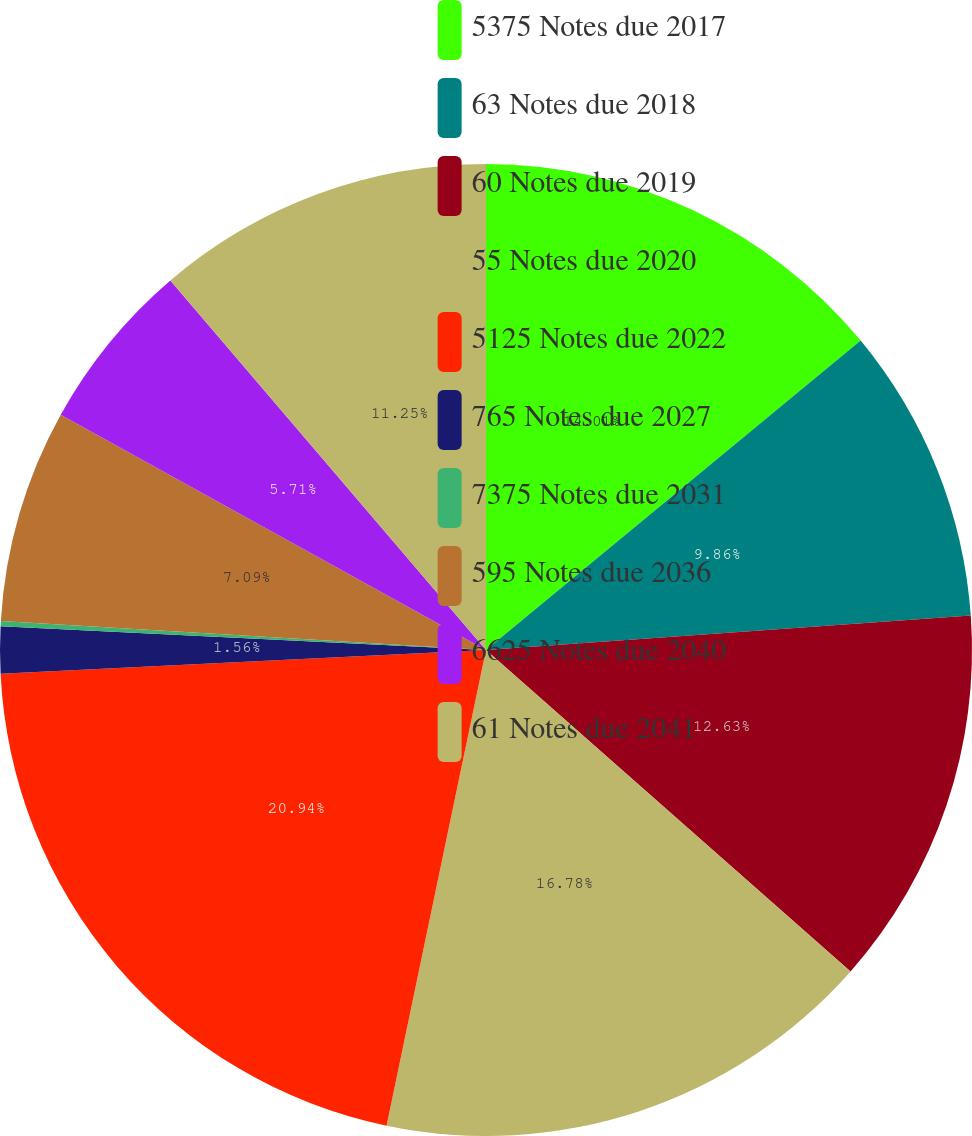<chart> <loc_0><loc_0><loc_500><loc_500><pie_chart><fcel>5375 Notes due 2017<fcel>63 Notes due 2018<fcel>60 Notes due 2019<fcel>55 Notes due 2020<fcel>5125 Notes due 2022<fcel>765 Notes due 2027<fcel>7375 Notes due 2031<fcel>595 Notes due 2036<fcel>6625 Notes due 2040<fcel>61 Notes due 2041<nl><fcel>14.01%<fcel>9.86%<fcel>12.63%<fcel>16.78%<fcel>20.94%<fcel>1.56%<fcel>0.17%<fcel>7.09%<fcel>5.71%<fcel>11.25%<nl></chart> 